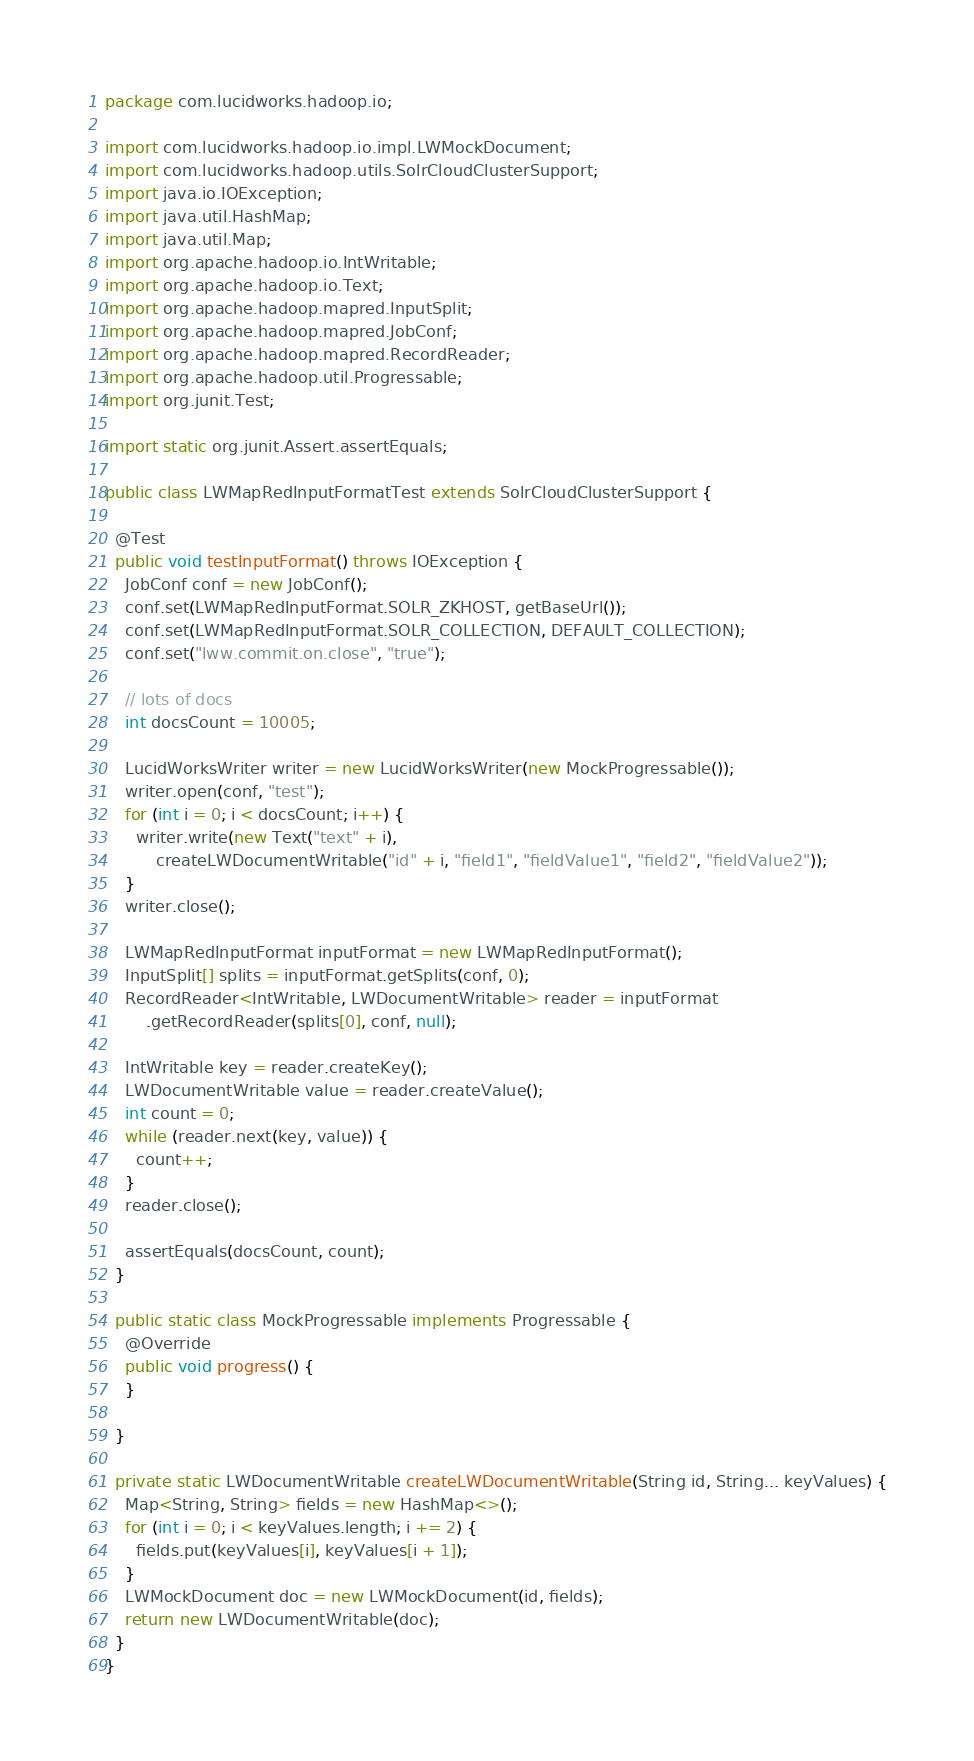Convert code to text. <code><loc_0><loc_0><loc_500><loc_500><_Java_>package com.lucidworks.hadoop.io;

import com.lucidworks.hadoop.io.impl.LWMockDocument;
import com.lucidworks.hadoop.utils.SolrCloudClusterSupport;
import java.io.IOException;
import java.util.HashMap;
import java.util.Map;
import org.apache.hadoop.io.IntWritable;
import org.apache.hadoop.io.Text;
import org.apache.hadoop.mapred.InputSplit;
import org.apache.hadoop.mapred.JobConf;
import org.apache.hadoop.mapred.RecordReader;
import org.apache.hadoop.util.Progressable;
import org.junit.Test;

import static org.junit.Assert.assertEquals;

public class LWMapRedInputFormatTest extends SolrCloudClusterSupport {

  @Test
  public void testInputFormat() throws IOException {
    JobConf conf = new JobConf();
    conf.set(LWMapRedInputFormat.SOLR_ZKHOST, getBaseUrl());
    conf.set(LWMapRedInputFormat.SOLR_COLLECTION, DEFAULT_COLLECTION);
    conf.set("lww.commit.on.close", "true");

    // lots of docs
    int docsCount = 10005;

    LucidWorksWriter writer = new LucidWorksWriter(new MockProgressable());
    writer.open(conf, "test");
    for (int i = 0; i < docsCount; i++) {
      writer.write(new Text("text" + i),
          createLWDocumentWritable("id" + i, "field1", "fieldValue1", "field2", "fieldValue2"));
    }
    writer.close();

    LWMapRedInputFormat inputFormat = new LWMapRedInputFormat();
    InputSplit[] splits = inputFormat.getSplits(conf, 0);
    RecordReader<IntWritable, LWDocumentWritable> reader = inputFormat
        .getRecordReader(splits[0], conf, null);

    IntWritable key = reader.createKey();
    LWDocumentWritable value = reader.createValue();
    int count = 0;
    while (reader.next(key, value)) {
      count++;
    }
    reader.close();

    assertEquals(docsCount, count);
  }

  public static class MockProgressable implements Progressable {
    @Override
    public void progress() {
    }

  }

  private static LWDocumentWritable createLWDocumentWritable(String id, String... keyValues) {
    Map<String, String> fields = new HashMap<>();
    for (int i = 0; i < keyValues.length; i += 2) {
      fields.put(keyValues[i], keyValues[i + 1]);
    }
    LWMockDocument doc = new LWMockDocument(id, fields);
    return new LWDocumentWritable(doc);
  }
}
</code> 